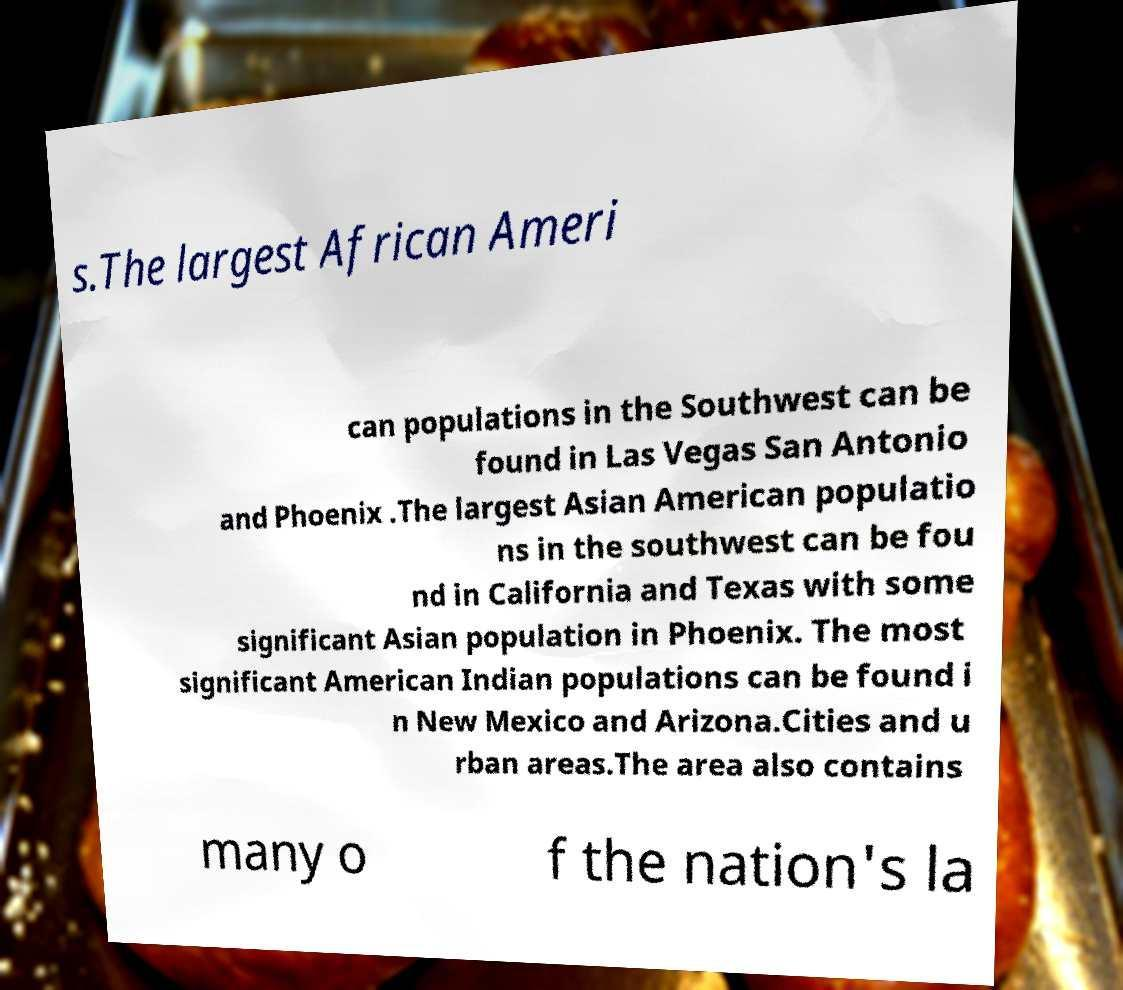Can you read and provide the text displayed in the image?This photo seems to have some interesting text. Can you extract and type it out for me? s.The largest African Ameri can populations in the Southwest can be found in Las Vegas San Antonio and Phoenix .The largest Asian American populatio ns in the southwest can be fou nd in California and Texas with some significant Asian population in Phoenix. The most significant American Indian populations can be found i n New Mexico and Arizona.Cities and u rban areas.The area also contains many o f the nation's la 